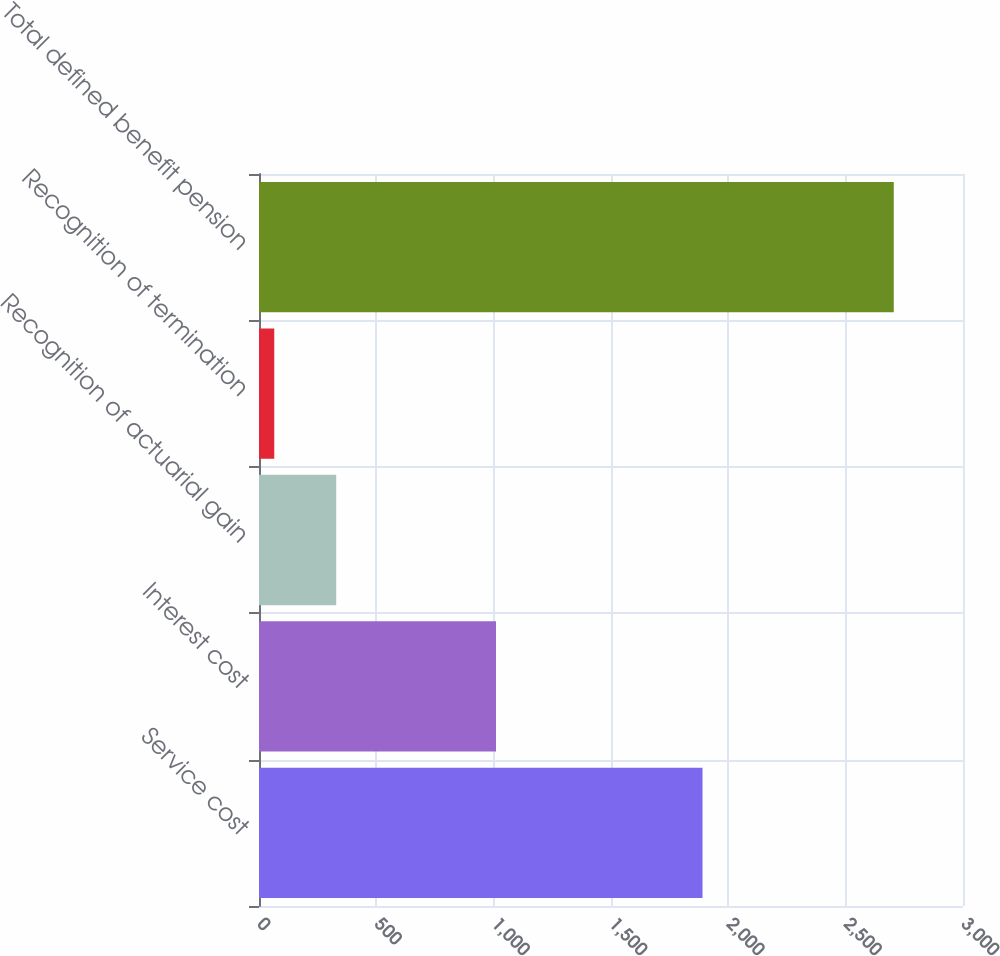Convert chart to OTSL. <chart><loc_0><loc_0><loc_500><loc_500><bar_chart><fcel>Service cost<fcel>Interest cost<fcel>Recognition of actuarial gain<fcel>Recognition of termination<fcel>Total defined benefit pension<nl><fcel>1890<fcel>1010<fcel>329<fcel>65<fcel>2705<nl></chart> 